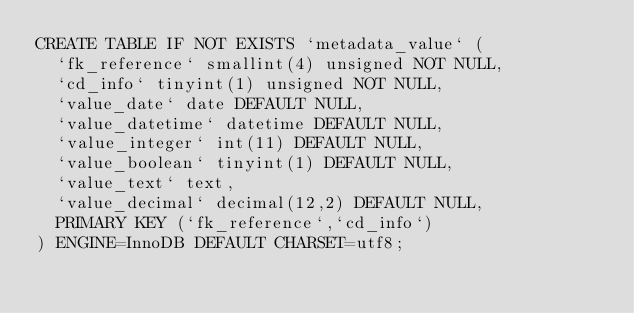<code> <loc_0><loc_0><loc_500><loc_500><_SQL_>CREATE TABLE IF NOT EXISTS `metadata_value` (
  `fk_reference` smallint(4) unsigned NOT NULL,
  `cd_info` tinyint(1) unsigned NOT NULL,
  `value_date` date DEFAULT NULL,
  `value_datetime` datetime DEFAULT NULL,
  `value_integer` int(11) DEFAULT NULL,
  `value_boolean` tinyint(1) DEFAULT NULL,
  `value_text` text,
  `value_decimal` decimal(12,2) DEFAULT NULL,
  PRIMARY KEY (`fk_reference`,`cd_info`)
) ENGINE=InnoDB DEFAULT CHARSET=utf8;
</code> 